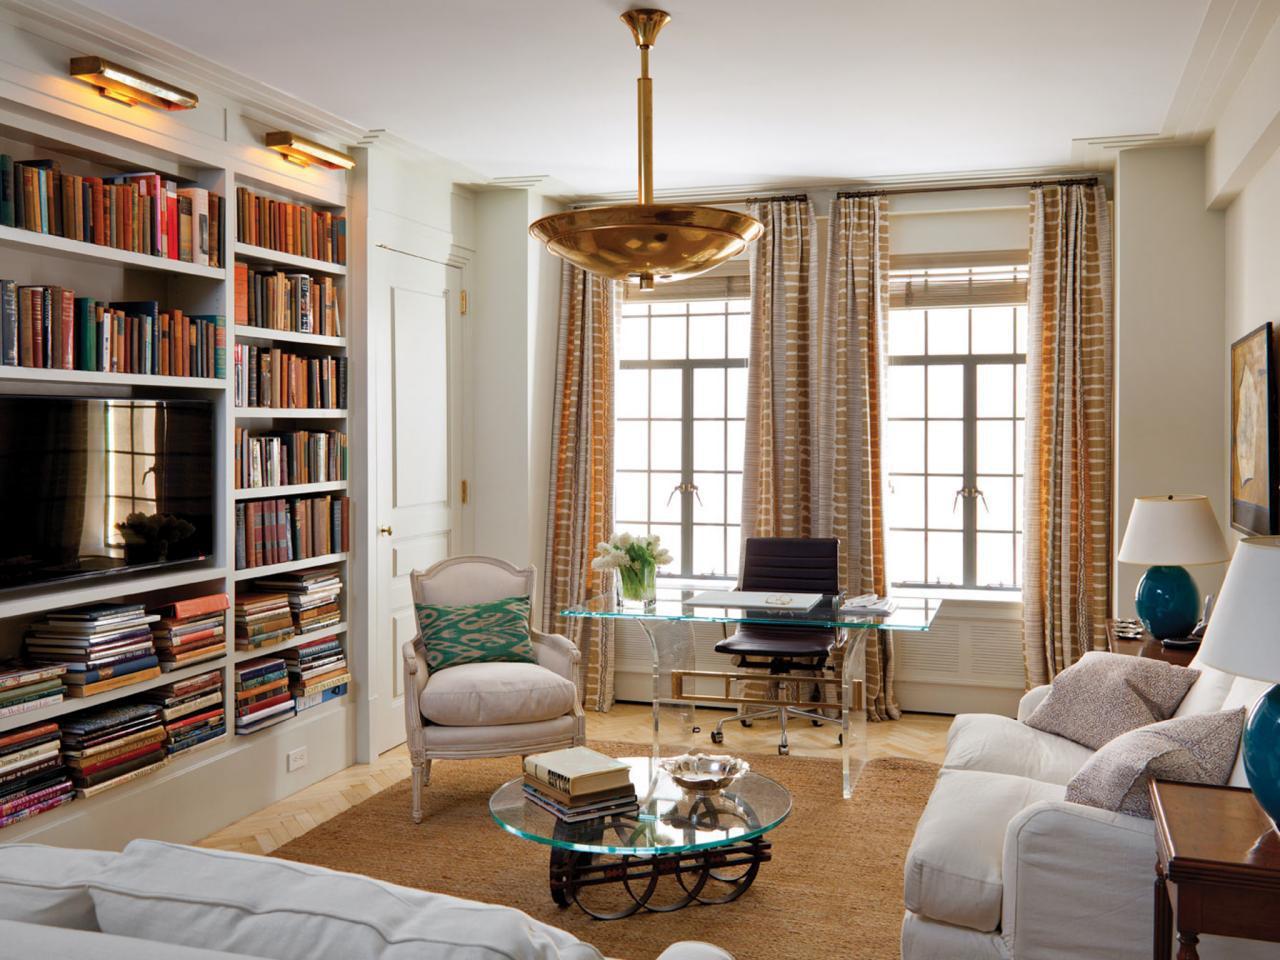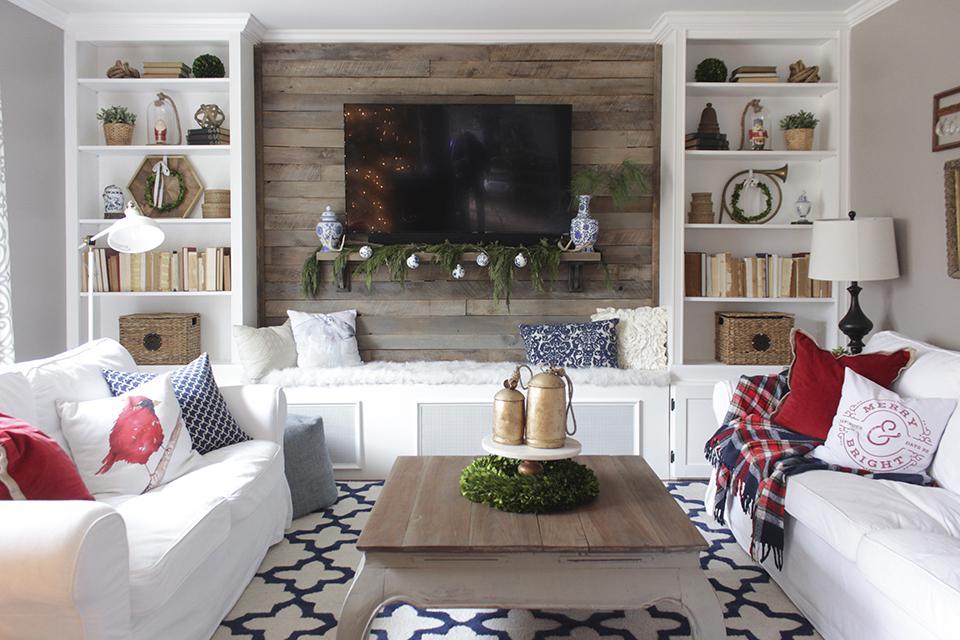The first image is the image on the left, the second image is the image on the right. Analyze the images presented: Is the assertion "In one room, the back of a sofa is against the wall containing bookshelves and behind an oriental-type rug." valid? Answer yes or no. No. 